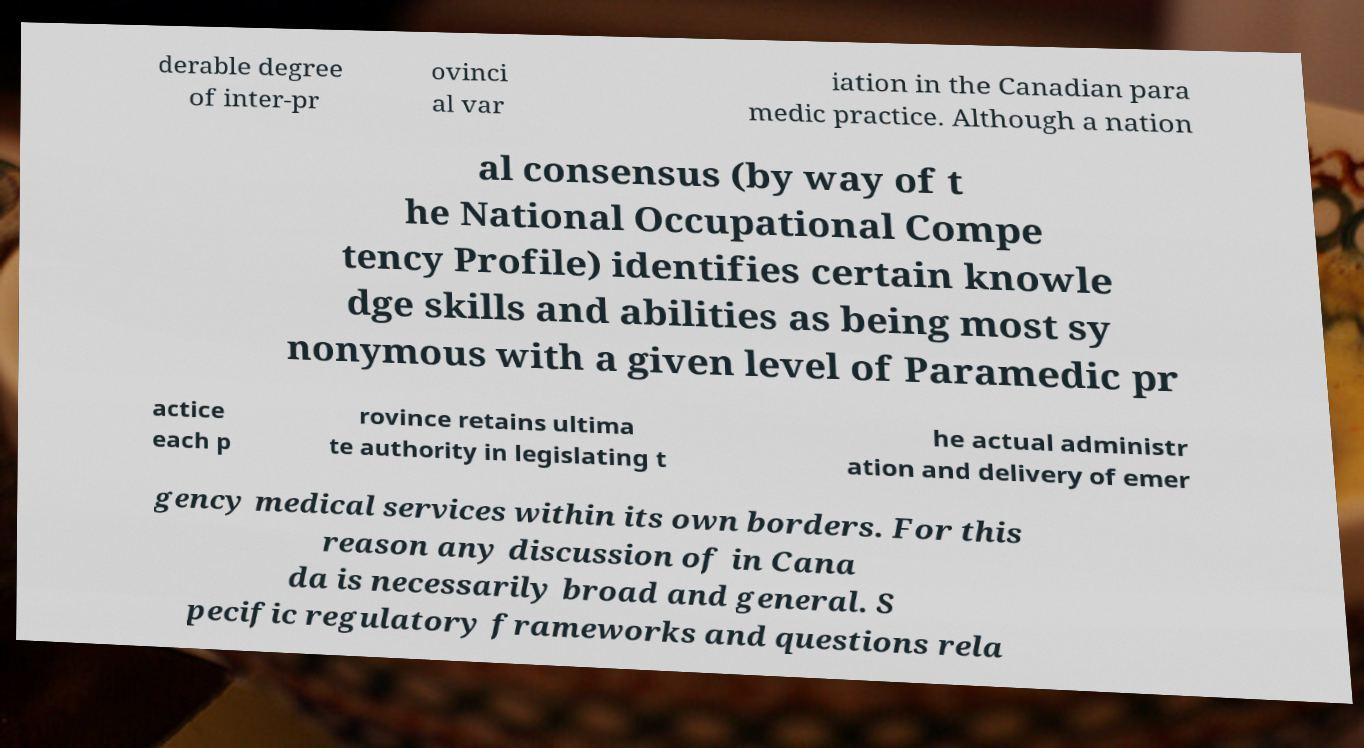Can you read and provide the text displayed in the image?This photo seems to have some interesting text. Can you extract and type it out for me? derable degree of inter-pr ovinci al var iation in the Canadian para medic practice. Although a nation al consensus (by way of t he National Occupational Compe tency Profile) identifies certain knowle dge skills and abilities as being most sy nonymous with a given level of Paramedic pr actice each p rovince retains ultima te authority in legislating t he actual administr ation and delivery of emer gency medical services within its own borders. For this reason any discussion of in Cana da is necessarily broad and general. S pecific regulatory frameworks and questions rela 